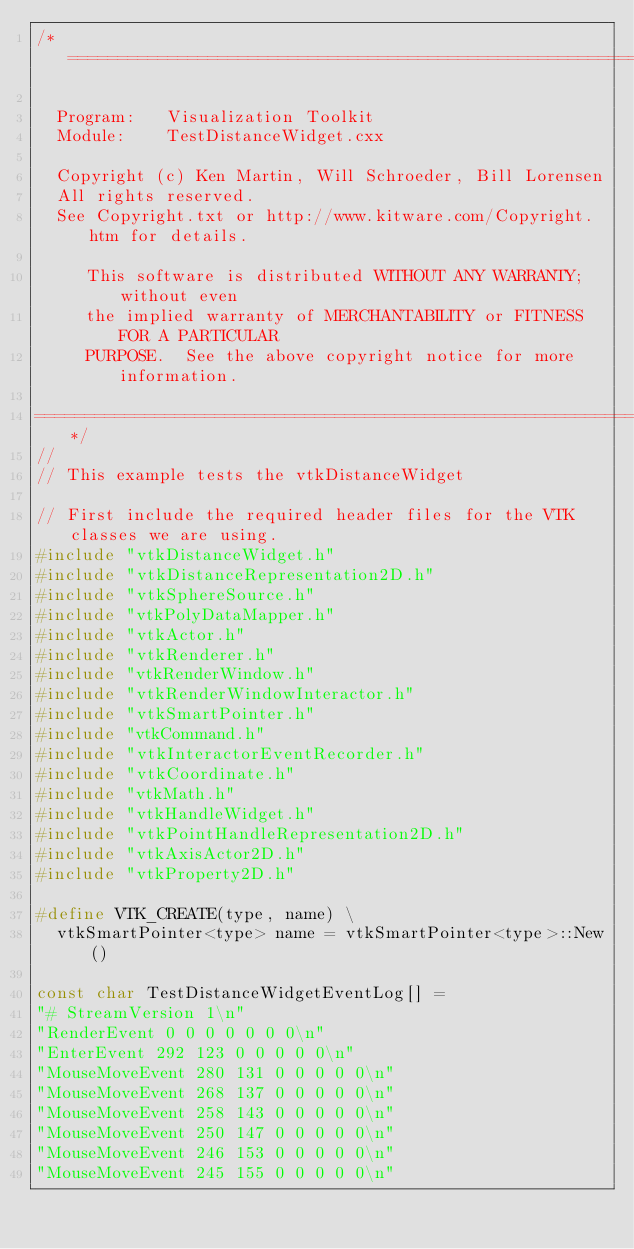<code> <loc_0><loc_0><loc_500><loc_500><_C++_>/*=========================================================================

  Program:   Visualization Toolkit
  Module:    TestDistanceWidget.cxx

  Copyright (c) Ken Martin, Will Schroeder, Bill Lorensen
  All rights reserved.
  See Copyright.txt or http://www.kitware.com/Copyright.htm for details.

     This software is distributed WITHOUT ANY WARRANTY; without even
     the implied warranty of MERCHANTABILITY or FITNESS FOR A PARTICULAR
     PURPOSE.  See the above copyright notice for more information.

=========================================================================*/
//
// This example tests the vtkDistanceWidget

// First include the required header files for the VTK classes we are using.
#include "vtkDistanceWidget.h"
#include "vtkDistanceRepresentation2D.h"
#include "vtkSphereSource.h"
#include "vtkPolyDataMapper.h"
#include "vtkActor.h"
#include "vtkRenderer.h"
#include "vtkRenderWindow.h"
#include "vtkRenderWindowInteractor.h"
#include "vtkSmartPointer.h"
#include "vtkCommand.h"
#include "vtkInteractorEventRecorder.h"
#include "vtkCoordinate.h"
#include "vtkMath.h"
#include "vtkHandleWidget.h"
#include "vtkPointHandleRepresentation2D.h"
#include "vtkAxisActor2D.h"
#include "vtkProperty2D.h"

#define VTK_CREATE(type, name) \
  vtkSmartPointer<type> name = vtkSmartPointer<type>::New()

const char TestDistanceWidgetEventLog[] =
"# StreamVersion 1\n"
"RenderEvent 0 0 0 0 0 0 0\n"
"EnterEvent 292 123 0 0 0 0 0\n"
"MouseMoveEvent 280 131 0 0 0 0 0\n"
"MouseMoveEvent 268 137 0 0 0 0 0\n"
"MouseMoveEvent 258 143 0 0 0 0 0\n"
"MouseMoveEvent 250 147 0 0 0 0 0\n"
"MouseMoveEvent 246 153 0 0 0 0 0\n"
"MouseMoveEvent 245 155 0 0 0 0 0\n"</code> 